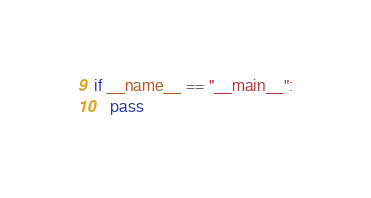<code> <loc_0><loc_0><loc_500><loc_500><_Python_>
if __name__ == "__main__":
    pass
</code> 